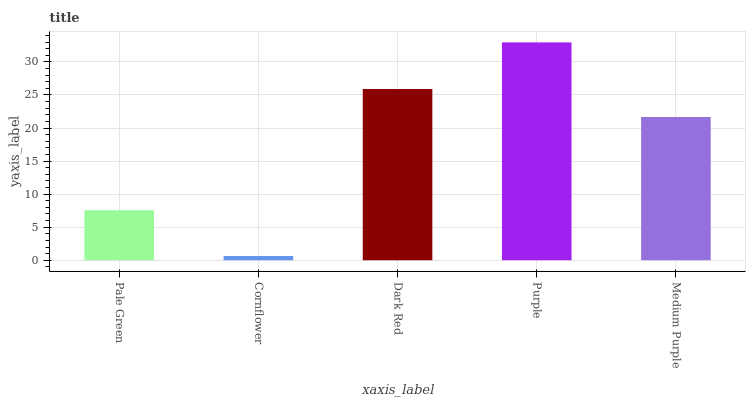Is Dark Red the minimum?
Answer yes or no. No. Is Dark Red the maximum?
Answer yes or no. No. Is Dark Red greater than Cornflower?
Answer yes or no. Yes. Is Cornflower less than Dark Red?
Answer yes or no. Yes. Is Cornflower greater than Dark Red?
Answer yes or no. No. Is Dark Red less than Cornflower?
Answer yes or no. No. Is Medium Purple the high median?
Answer yes or no. Yes. Is Medium Purple the low median?
Answer yes or no. Yes. Is Dark Red the high median?
Answer yes or no. No. Is Dark Red the low median?
Answer yes or no. No. 